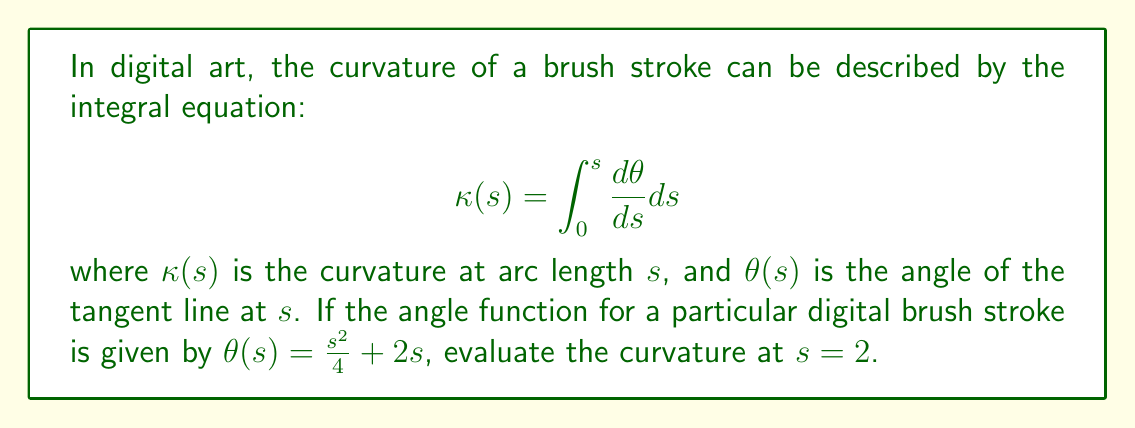Solve this math problem. Let's approach this step-by-step:

1) We start with the given integral equation for curvature:
   $$\kappa(s) = \int_0^s \frac{d\theta}{ds} ds$$

2) We're given the angle function $\theta(s) = \frac{s^2}{4} + 2s$

3) To find $\frac{d\theta}{ds}$, we need to differentiate $\theta(s)$ with respect to $s$:
   $$\frac{d\theta}{ds} = \frac{d}{ds}(\frac{s^2}{4} + 2s) = \frac{s}{2} + 2$$

4) Now we can rewrite our integral:
   $$\kappa(s) = \int_0^s (\frac{s}{2} + 2) ds$$

5) To evaluate the curvature at $s = 2$, we need to integrate from 0 to 2:
   $$\kappa(2) = \int_0^2 (\frac{s}{2} + 2) ds$$

6) Let's solve this integral:
   $$\kappa(2) = [\frac{s^2}{4} + 2s]_0^2$$

7) Evaluating the antiderivative at the limits:
   $$\kappa(2) = (\frac{2^2}{4} + 2(2)) - (\frac{0^2}{4} + 2(0)) = (1 + 4) - 0 = 5$$

Therefore, the curvature of the digital brush stroke at $s = 2$ is 5.
Answer: $5$ 